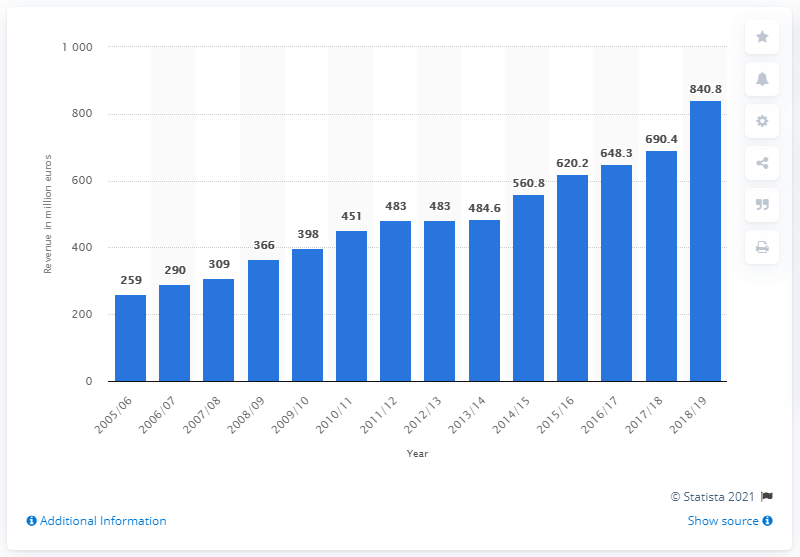Draw attention to some important aspects in this diagram. In the 2018/19 season, Barcelona generated a revenue of 840.8 million euros. 